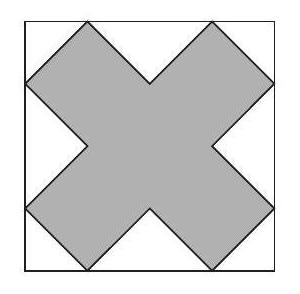Can you explain how the shape of the dodecagon fits within the square? In the image, the dodecagon appears to be structured from right-angled triangles at each corner of the square. These triangles meet at the center, forming a cross that outlines the dodecagon. This arrangement allows the square to encapsulate the dodecagon neatly, maximizing the area used within the square. 